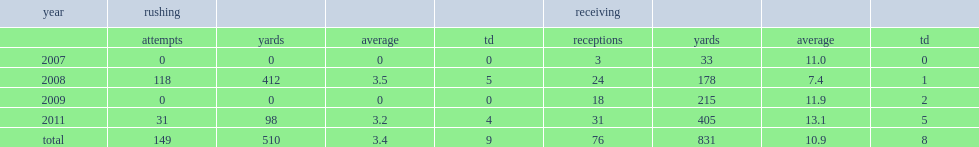How many receiving yards did lamark brown get in 2009? 215.0. 